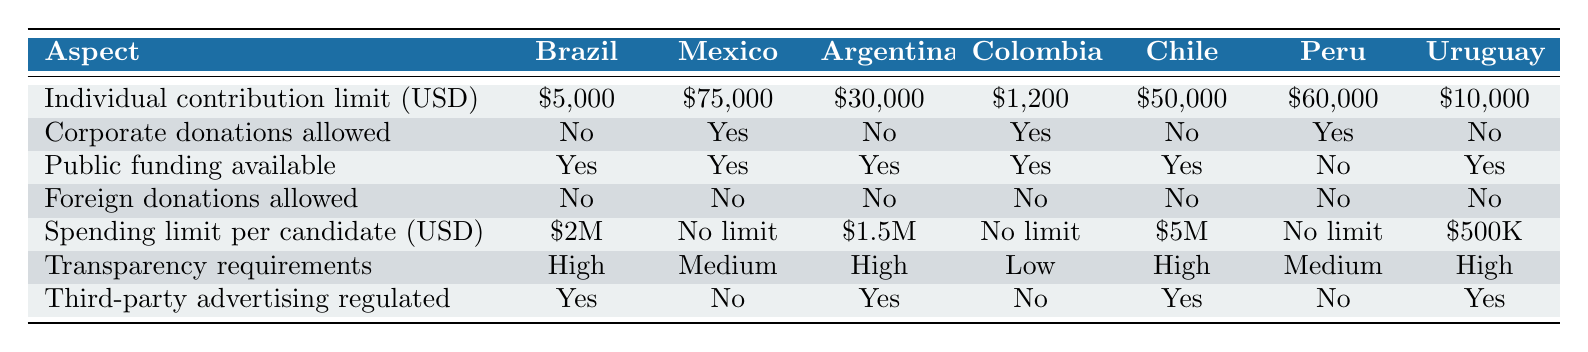What is the individual contribution limit in Brazil? According to the table, the individual contribution limit in Brazil is listed as $5,000.
Answer: $5,000 Do any countries allow corporate donations? By checking the table, it is noted that Mexico, Colombia, and Peru allow corporate donations, while others do not.
Answer: Yes, three countries allow corporate donations Which country has the highest individual contribution limit? Reviewing the limits, Mexico has the highest individual contribution limit of $75,000.
Answer: Mexico Is there public funding available in Chile? The table indicates that public funding is available in Chile, confirmed by the "Yes" entry.
Answer: Yes What is the spending limit per candidate in Argentina? The entry for Argentina shows that the spending limit per candidate is $1.5 million.
Answer: $1.5M What is the average individual contribution limit for the listed countries? The individual contribution limits are $5,000 (Brazil), $75,000 (Mexico), $30,000 (Argentina), $1,200 (Colombia), $50,000 (Chile), $60,000 (Peru), and $10,000 (Uruguay). Summing these values gives $231,200, and dividing by 7 gives an average of $33,028.57.
Answer: $33,028.57 How many countries have high transparency requirements? The table lists Brazil, Argentina, Chile, and Uruguay as having high transparency requirements, a total of four countries.
Answer: Four countries Which countries do not allow foreign donations? Since foreign donations are not allowed according to the table for all countries, all countries listed do not allow foreign donations.
Answer: All countries What is the spending limit for candidates in Colombia and Peru combined? In Colombia, there is no spending limit, and in Peru, the spending limit is $500,000. Since there is no limit (considered infinite), the combined spending limit is categorized as infinite.
Answer: Infinite How does the public funding status compare between Colombia and Peru? Both Colombia and Peru have public funding available and not available respectively — Colombia has it while Peru does not.
Answer: Colombia has public funding; Peru does not 